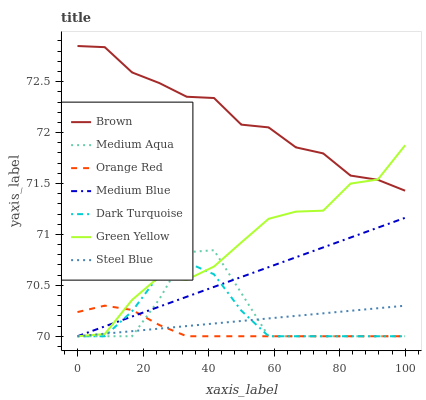Does Orange Red have the minimum area under the curve?
Answer yes or no. Yes. Does Brown have the maximum area under the curve?
Answer yes or no. Yes. Does Dark Turquoise have the minimum area under the curve?
Answer yes or no. No. Does Dark Turquoise have the maximum area under the curve?
Answer yes or no. No. Is Medium Blue the smoothest?
Answer yes or no. Yes. Is Green Yellow the roughest?
Answer yes or no. Yes. Is Dark Turquoise the smoothest?
Answer yes or no. No. Is Dark Turquoise the roughest?
Answer yes or no. No. Does Brown have the highest value?
Answer yes or no. Yes. Does Dark Turquoise have the highest value?
Answer yes or no. No. Is Dark Turquoise less than Brown?
Answer yes or no. Yes. Is Brown greater than Medium Aqua?
Answer yes or no. Yes. Does Dark Turquoise intersect Brown?
Answer yes or no. No. 